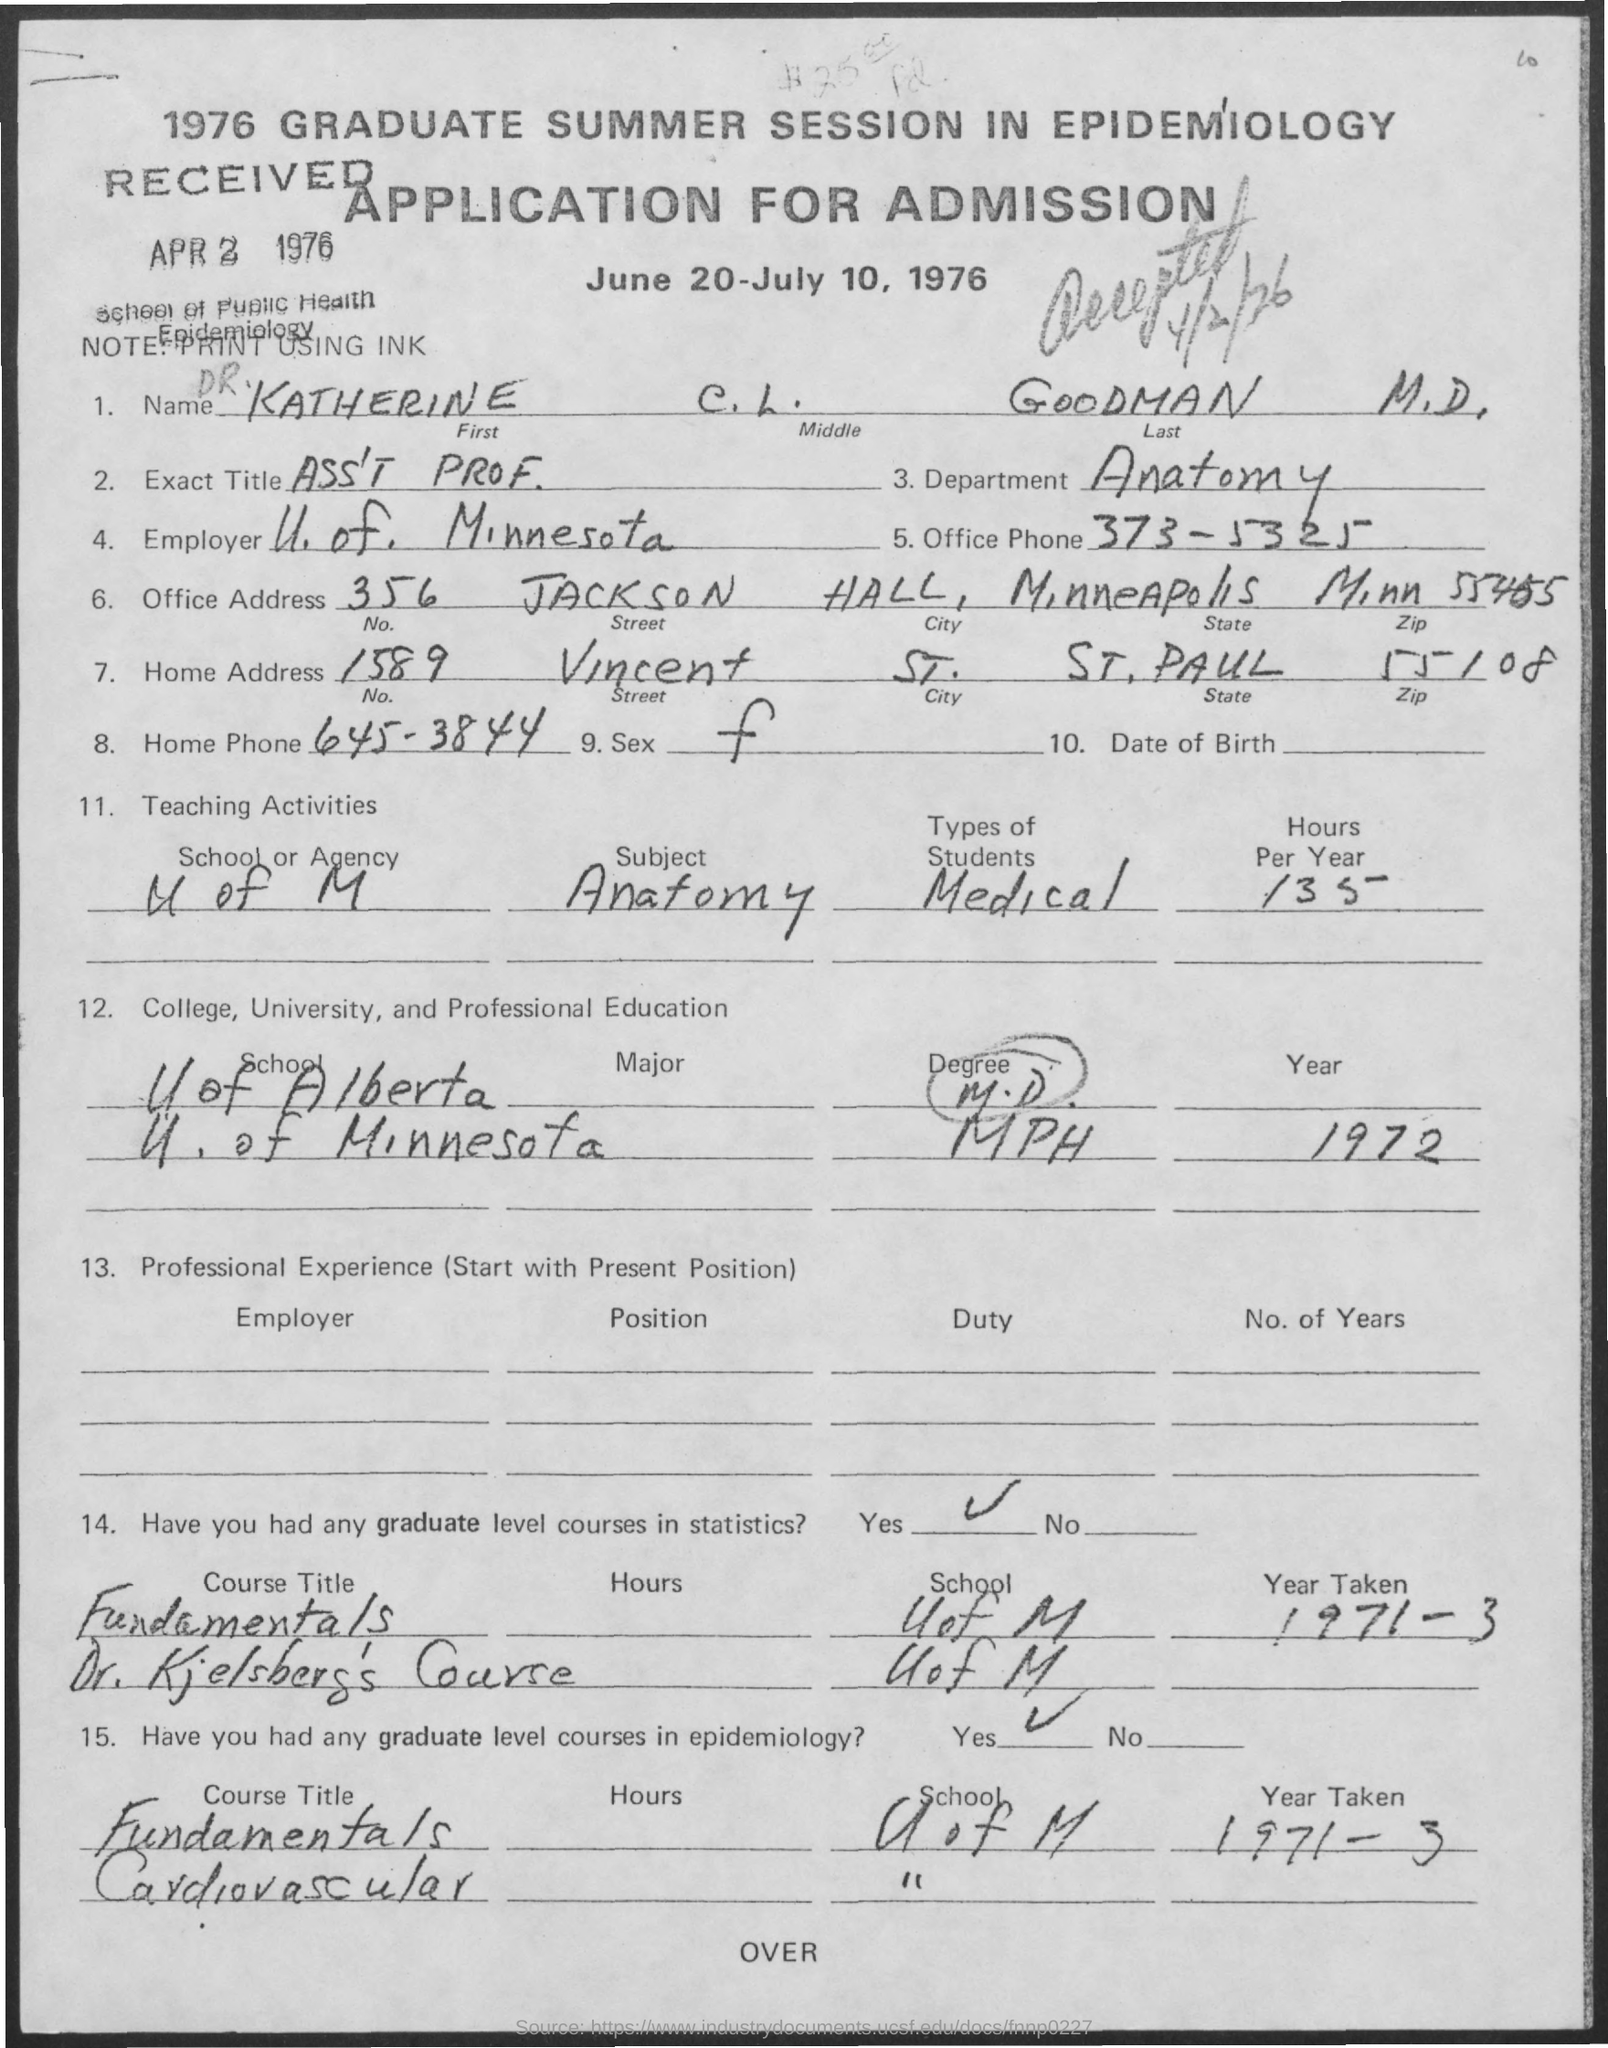List a handful of essential elements in this visual. The applicant took a graduate level course on the fundamentals of epidemiology during the period of 1971-3. The University of Minnesota is the employer. The applicant's name is Katherine. The applicant took a statistics course at the University of M.. This application is for the 1976 Graduate summer session in Epidemiology. 